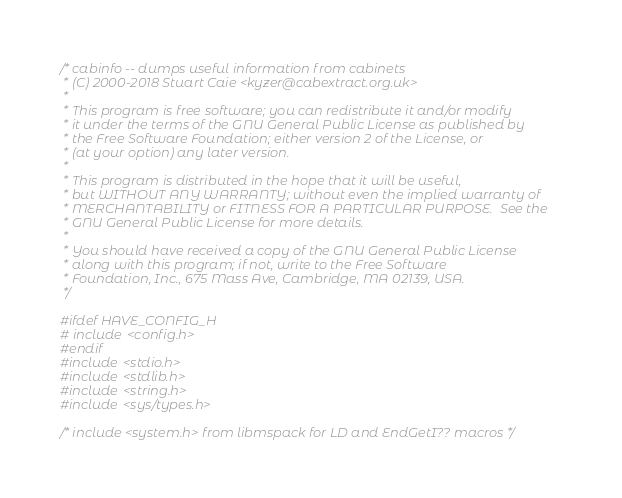Convert code to text. <code><loc_0><loc_0><loc_500><loc_500><_C_>/* cabinfo -- dumps useful information from cabinets
 * (C) 2000-2018 Stuart Caie <kyzer@cabextract.org.uk>
 *
 * This program is free software; you can redistribute it and/or modify
 * it under the terms of the GNU General Public License as published by
 * the Free Software Foundation; either version 2 of the License, or
 * (at your option) any later version.
 *
 * This program is distributed in the hope that it will be useful,
 * but WITHOUT ANY WARRANTY; without even the implied warranty of
 * MERCHANTABILITY or FITNESS FOR A PARTICULAR PURPOSE.  See the
 * GNU General Public License for more details.
 *
 * You should have received a copy of the GNU General Public License
 * along with this program; if not, write to the Free Software
 * Foundation, Inc., 675 Mass Ave, Cambridge, MA 02139, USA.
 */

#ifdef HAVE_CONFIG_H
# include <config.h>
#endif
#include <stdio.h>
#include <stdlib.h>
#include <string.h>
#include <sys/types.h>

/* include <system.h> from libmspack for LD and EndGetI?? macros */</code> 